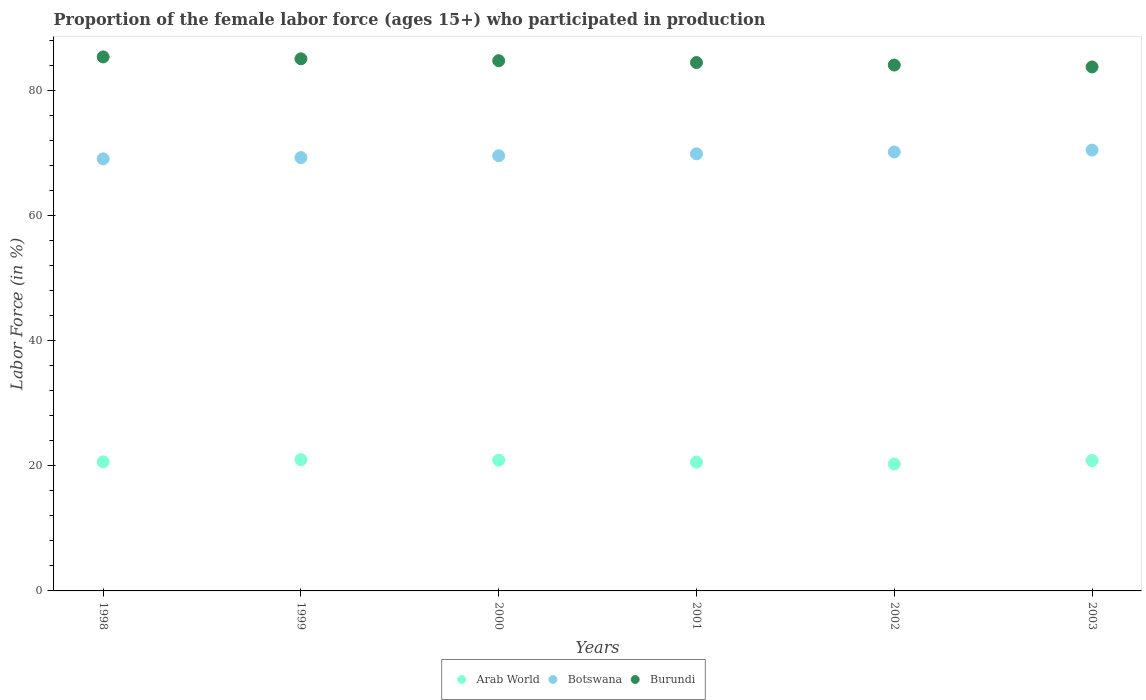What is the proportion of the female labor force who participated in production in Arab World in 2000?
Ensure brevity in your answer.  20.91. Across all years, what is the maximum proportion of the female labor force who participated in production in Burundi?
Ensure brevity in your answer.  85.4. Across all years, what is the minimum proportion of the female labor force who participated in production in Burundi?
Give a very brief answer. 83.8. What is the total proportion of the female labor force who participated in production in Burundi in the graph?
Ensure brevity in your answer.  507.7. What is the difference between the proportion of the female labor force who participated in production in Burundi in 2000 and the proportion of the female labor force who participated in production in Arab World in 2001?
Your answer should be compact. 64.21. What is the average proportion of the female labor force who participated in production in Burundi per year?
Your response must be concise. 84.62. In the year 1999, what is the difference between the proportion of the female labor force who participated in production in Arab World and proportion of the female labor force who participated in production in Burundi?
Ensure brevity in your answer.  -64.11. In how many years, is the proportion of the female labor force who participated in production in Arab World greater than 72 %?
Keep it short and to the point. 0. What is the ratio of the proportion of the female labor force who participated in production in Botswana in 2000 to that in 2003?
Offer a very short reply. 0.99. Is the difference between the proportion of the female labor force who participated in production in Arab World in 1999 and 2001 greater than the difference between the proportion of the female labor force who participated in production in Burundi in 1999 and 2001?
Your response must be concise. No. What is the difference between the highest and the second highest proportion of the female labor force who participated in production in Burundi?
Offer a very short reply. 0.3. What is the difference between the highest and the lowest proportion of the female labor force who participated in production in Arab World?
Provide a short and direct response. 0.69. In how many years, is the proportion of the female labor force who participated in production in Arab World greater than the average proportion of the female labor force who participated in production in Arab World taken over all years?
Make the answer very short. 3. Does the proportion of the female labor force who participated in production in Burundi monotonically increase over the years?
Give a very brief answer. No. Is the proportion of the female labor force who participated in production in Burundi strictly greater than the proportion of the female labor force who participated in production in Botswana over the years?
Provide a succinct answer. Yes. How many dotlines are there?
Give a very brief answer. 3. How many years are there in the graph?
Your answer should be very brief. 6. How many legend labels are there?
Ensure brevity in your answer.  3. What is the title of the graph?
Keep it short and to the point. Proportion of the female labor force (ages 15+) who participated in production. What is the label or title of the X-axis?
Make the answer very short. Years. What is the label or title of the Y-axis?
Your response must be concise. Labor Force (in %). What is the Labor Force (in %) of Arab World in 1998?
Provide a succinct answer. 20.64. What is the Labor Force (in %) in Botswana in 1998?
Your answer should be compact. 69.1. What is the Labor Force (in %) of Burundi in 1998?
Your answer should be very brief. 85.4. What is the Labor Force (in %) of Arab World in 1999?
Your answer should be compact. 20.99. What is the Labor Force (in %) in Botswana in 1999?
Offer a very short reply. 69.3. What is the Labor Force (in %) in Burundi in 1999?
Ensure brevity in your answer.  85.1. What is the Labor Force (in %) of Arab World in 2000?
Your response must be concise. 20.91. What is the Labor Force (in %) in Botswana in 2000?
Offer a very short reply. 69.6. What is the Labor Force (in %) in Burundi in 2000?
Make the answer very short. 84.8. What is the Labor Force (in %) of Arab World in 2001?
Make the answer very short. 20.59. What is the Labor Force (in %) in Botswana in 2001?
Offer a very short reply. 69.9. What is the Labor Force (in %) in Burundi in 2001?
Ensure brevity in your answer.  84.5. What is the Labor Force (in %) in Arab World in 2002?
Provide a succinct answer. 20.3. What is the Labor Force (in %) in Botswana in 2002?
Offer a very short reply. 70.2. What is the Labor Force (in %) of Burundi in 2002?
Provide a succinct answer. 84.1. What is the Labor Force (in %) of Arab World in 2003?
Give a very brief answer. 20.85. What is the Labor Force (in %) in Botswana in 2003?
Give a very brief answer. 70.5. What is the Labor Force (in %) in Burundi in 2003?
Give a very brief answer. 83.8. Across all years, what is the maximum Labor Force (in %) in Arab World?
Ensure brevity in your answer.  20.99. Across all years, what is the maximum Labor Force (in %) of Botswana?
Keep it short and to the point. 70.5. Across all years, what is the maximum Labor Force (in %) of Burundi?
Offer a terse response. 85.4. Across all years, what is the minimum Labor Force (in %) of Arab World?
Your answer should be compact. 20.3. Across all years, what is the minimum Labor Force (in %) of Botswana?
Give a very brief answer. 69.1. Across all years, what is the minimum Labor Force (in %) of Burundi?
Your response must be concise. 83.8. What is the total Labor Force (in %) of Arab World in the graph?
Provide a short and direct response. 124.28. What is the total Labor Force (in %) in Botswana in the graph?
Your answer should be very brief. 418.6. What is the total Labor Force (in %) in Burundi in the graph?
Your answer should be compact. 507.7. What is the difference between the Labor Force (in %) in Arab World in 1998 and that in 1999?
Provide a succinct answer. -0.35. What is the difference between the Labor Force (in %) in Botswana in 1998 and that in 1999?
Offer a terse response. -0.2. What is the difference between the Labor Force (in %) in Arab World in 1998 and that in 2000?
Offer a very short reply. -0.27. What is the difference between the Labor Force (in %) of Botswana in 1998 and that in 2000?
Keep it short and to the point. -0.5. What is the difference between the Labor Force (in %) of Burundi in 1998 and that in 2000?
Provide a succinct answer. 0.6. What is the difference between the Labor Force (in %) in Arab World in 1998 and that in 2001?
Give a very brief answer. 0.05. What is the difference between the Labor Force (in %) of Arab World in 1998 and that in 2002?
Your response must be concise. 0.34. What is the difference between the Labor Force (in %) in Burundi in 1998 and that in 2002?
Offer a terse response. 1.3. What is the difference between the Labor Force (in %) in Arab World in 1998 and that in 2003?
Ensure brevity in your answer.  -0.21. What is the difference between the Labor Force (in %) of Botswana in 1998 and that in 2003?
Keep it short and to the point. -1.4. What is the difference between the Labor Force (in %) of Arab World in 1999 and that in 2000?
Offer a very short reply. 0.08. What is the difference between the Labor Force (in %) in Botswana in 1999 and that in 2000?
Offer a terse response. -0.3. What is the difference between the Labor Force (in %) of Arab World in 1999 and that in 2001?
Your answer should be compact. 0.4. What is the difference between the Labor Force (in %) of Botswana in 1999 and that in 2001?
Your response must be concise. -0.6. What is the difference between the Labor Force (in %) in Burundi in 1999 and that in 2001?
Provide a short and direct response. 0.6. What is the difference between the Labor Force (in %) in Arab World in 1999 and that in 2002?
Give a very brief answer. 0.69. What is the difference between the Labor Force (in %) of Burundi in 1999 and that in 2002?
Your answer should be compact. 1. What is the difference between the Labor Force (in %) in Arab World in 1999 and that in 2003?
Provide a succinct answer. 0.14. What is the difference between the Labor Force (in %) of Burundi in 1999 and that in 2003?
Offer a terse response. 1.3. What is the difference between the Labor Force (in %) of Arab World in 2000 and that in 2001?
Your response must be concise. 0.32. What is the difference between the Labor Force (in %) in Burundi in 2000 and that in 2001?
Your response must be concise. 0.3. What is the difference between the Labor Force (in %) in Arab World in 2000 and that in 2002?
Provide a short and direct response. 0.61. What is the difference between the Labor Force (in %) of Burundi in 2000 and that in 2002?
Your answer should be very brief. 0.7. What is the difference between the Labor Force (in %) of Arab World in 2000 and that in 2003?
Keep it short and to the point. 0.07. What is the difference between the Labor Force (in %) in Botswana in 2000 and that in 2003?
Your response must be concise. -0.9. What is the difference between the Labor Force (in %) of Arab World in 2001 and that in 2002?
Ensure brevity in your answer.  0.29. What is the difference between the Labor Force (in %) in Arab World in 2001 and that in 2003?
Keep it short and to the point. -0.25. What is the difference between the Labor Force (in %) in Burundi in 2001 and that in 2003?
Offer a very short reply. 0.7. What is the difference between the Labor Force (in %) of Arab World in 2002 and that in 2003?
Make the answer very short. -0.55. What is the difference between the Labor Force (in %) of Botswana in 2002 and that in 2003?
Offer a very short reply. -0.3. What is the difference between the Labor Force (in %) of Burundi in 2002 and that in 2003?
Offer a terse response. 0.3. What is the difference between the Labor Force (in %) in Arab World in 1998 and the Labor Force (in %) in Botswana in 1999?
Your response must be concise. -48.66. What is the difference between the Labor Force (in %) in Arab World in 1998 and the Labor Force (in %) in Burundi in 1999?
Offer a terse response. -64.46. What is the difference between the Labor Force (in %) of Arab World in 1998 and the Labor Force (in %) of Botswana in 2000?
Ensure brevity in your answer.  -48.96. What is the difference between the Labor Force (in %) of Arab World in 1998 and the Labor Force (in %) of Burundi in 2000?
Provide a short and direct response. -64.16. What is the difference between the Labor Force (in %) of Botswana in 1998 and the Labor Force (in %) of Burundi in 2000?
Keep it short and to the point. -15.7. What is the difference between the Labor Force (in %) of Arab World in 1998 and the Labor Force (in %) of Botswana in 2001?
Ensure brevity in your answer.  -49.26. What is the difference between the Labor Force (in %) in Arab World in 1998 and the Labor Force (in %) in Burundi in 2001?
Ensure brevity in your answer.  -63.86. What is the difference between the Labor Force (in %) in Botswana in 1998 and the Labor Force (in %) in Burundi in 2001?
Keep it short and to the point. -15.4. What is the difference between the Labor Force (in %) of Arab World in 1998 and the Labor Force (in %) of Botswana in 2002?
Ensure brevity in your answer.  -49.56. What is the difference between the Labor Force (in %) of Arab World in 1998 and the Labor Force (in %) of Burundi in 2002?
Give a very brief answer. -63.46. What is the difference between the Labor Force (in %) in Arab World in 1998 and the Labor Force (in %) in Botswana in 2003?
Keep it short and to the point. -49.86. What is the difference between the Labor Force (in %) of Arab World in 1998 and the Labor Force (in %) of Burundi in 2003?
Provide a short and direct response. -63.16. What is the difference between the Labor Force (in %) in Botswana in 1998 and the Labor Force (in %) in Burundi in 2003?
Give a very brief answer. -14.7. What is the difference between the Labor Force (in %) in Arab World in 1999 and the Labor Force (in %) in Botswana in 2000?
Ensure brevity in your answer.  -48.61. What is the difference between the Labor Force (in %) in Arab World in 1999 and the Labor Force (in %) in Burundi in 2000?
Your response must be concise. -63.81. What is the difference between the Labor Force (in %) in Botswana in 1999 and the Labor Force (in %) in Burundi in 2000?
Your response must be concise. -15.5. What is the difference between the Labor Force (in %) in Arab World in 1999 and the Labor Force (in %) in Botswana in 2001?
Keep it short and to the point. -48.91. What is the difference between the Labor Force (in %) of Arab World in 1999 and the Labor Force (in %) of Burundi in 2001?
Keep it short and to the point. -63.51. What is the difference between the Labor Force (in %) in Botswana in 1999 and the Labor Force (in %) in Burundi in 2001?
Provide a succinct answer. -15.2. What is the difference between the Labor Force (in %) of Arab World in 1999 and the Labor Force (in %) of Botswana in 2002?
Ensure brevity in your answer.  -49.21. What is the difference between the Labor Force (in %) in Arab World in 1999 and the Labor Force (in %) in Burundi in 2002?
Provide a short and direct response. -63.11. What is the difference between the Labor Force (in %) of Botswana in 1999 and the Labor Force (in %) of Burundi in 2002?
Give a very brief answer. -14.8. What is the difference between the Labor Force (in %) in Arab World in 1999 and the Labor Force (in %) in Botswana in 2003?
Provide a succinct answer. -49.51. What is the difference between the Labor Force (in %) of Arab World in 1999 and the Labor Force (in %) of Burundi in 2003?
Offer a terse response. -62.81. What is the difference between the Labor Force (in %) in Botswana in 1999 and the Labor Force (in %) in Burundi in 2003?
Give a very brief answer. -14.5. What is the difference between the Labor Force (in %) of Arab World in 2000 and the Labor Force (in %) of Botswana in 2001?
Provide a succinct answer. -48.99. What is the difference between the Labor Force (in %) in Arab World in 2000 and the Labor Force (in %) in Burundi in 2001?
Make the answer very short. -63.59. What is the difference between the Labor Force (in %) of Botswana in 2000 and the Labor Force (in %) of Burundi in 2001?
Your answer should be compact. -14.9. What is the difference between the Labor Force (in %) in Arab World in 2000 and the Labor Force (in %) in Botswana in 2002?
Make the answer very short. -49.29. What is the difference between the Labor Force (in %) of Arab World in 2000 and the Labor Force (in %) of Burundi in 2002?
Give a very brief answer. -63.19. What is the difference between the Labor Force (in %) of Arab World in 2000 and the Labor Force (in %) of Botswana in 2003?
Keep it short and to the point. -49.59. What is the difference between the Labor Force (in %) of Arab World in 2000 and the Labor Force (in %) of Burundi in 2003?
Your answer should be very brief. -62.89. What is the difference between the Labor Force (in %) of Botswana in 2000 and the Labor Force (in %) of Burundi in 2003?
Offer a very short reply. -14.2. What is the difference between the Labor Force (in %) in Arab World in 2001 and the Labor Force (in %) in Botswana in 2002?
Your answer should be compact. -49.61. What is the difference between the Labor Force (in %) in Arab World in 2001 and the Labor Force (in %) in Burundi in 2002?
Provide a succinct answer. -63.51. What is the difference between the Labor Force (in %) of Arab World in 2001 and the Labor Force (in %) of Botswana in 2003?
Ensure brevity in your answer.  -49.91. What is the difference between the Labor Force (in %) in Arab World in 2001 and the Labor Force (in %) in Burundi in 2003?
Make the answer very short. -63.21. What is the difference between the Labor Force (in %) of Botswana in 2001 and the Labor Force (in %) of Burundi in 2003?
Keep it short and to the point. -13.9. What is the difference between the Labor Force (in %) in Arab World in 2002 and the Labor Force (in %) in Botswana in 2003?
Offer a terse response. -50.2. What is the difference between the Labor Force (in %) of Arab World in 2002 and the Labor Force (in %) of Burundi in 2003?
Make the answer very short. -63.5. What is the average Labor Force (in %) of Arab World per year?
Keep it short and to the point. 20.71. What is the average Labor Force (in %) in Botswana per year?
Provide a short and direct response. 69.77. What is the average Labor Force (in %) of Burundi per year?
Your answer should be compact. 84.62. In the year 1998, what is the difference between the Labor Force (in %) in Arab World and Labor Force (in %) in Botswana?
Offer a terse response. -48.46. In the year 1998, what is the difference between the Labor Force (in %) in Arab World and Labor Force (in %) in Burundi?
Make the answer very short. -64.76. In the year 1998, what is the difference between the Labor Force (in %) of Botswana and Labor Force (in %) of Burundi?
Provide a succinct answer. -16.3. In the year 1999, what is the difference between the Labor Force (in %) of Arab World and Labor Force (in %) of Botswana?
Your response must be concise. -48.31. In the year 1999, what is the difference between the Labor Force (in %) in Arab World and Labor Force (in %) in Burundi?
Give a very brief answer. -64.11. In the year 1999, what is the difference between the Labor Force (in %) of Botswana and Labor Force (in %) of Burundi?
Provide a short and direct response. -15.8. In the year 2000, what is the difference between the Labor Force (in %) of Arab World and Labor Force (in %) of Botswana?
Your response must be concise. -48.69. In the year 2000, what is the difference between the Labor Force (in %) of Arab World and Labor Force (in %) of Burundi?
Provide a short and direct response. -63.89. In the year 2000, what is the difference between the Labor Force (in %) in Botswana and Labor Force (in %) in Burundi?
Give a very brief answer. -15.2. In the year 2001, what is the difference between the Labor Force (in %) in Arab World and Labor Force (in %) in Botswana?
Your answer should be very brief. -49.31. In the year 2001, what is the difference between the Labor Force (in %) in Arab World and Labor Force (in %) in Burundi?
Provide a succinct answer. -63.91. In the year 2001, what is the difference between the Labor Force (in %) of Botswana and Labor Force (in %) of Burundi?
Make the answer very short. -14.6. In the year 2002, what is the difference between the Labor Force (in %) in Arab World and Labor Force (in %) in Botswana?
Make the answer very short. -49.9. In the year 2002, what is the difference between the Labor Force (in %) of Arab World and Labor Force (in %) of Burundi?
Your response must be concise. -63.8. In the year 2002, what is the difference between the Labor Force (in %) of Botswana and Labor Force (in %) of Burundi?
Provide a short and direct response. -13.9. In the year 2003, what is the difference between the Labor Force (in %) in Arab World and Labor Force (in %) in Botswana?
Your answer should be compact. -49.65. In the year 2003, what is the difference between the Labor Force (in %) of Arab World and Labor Force (in %) of Burundi?
Your response must be concise. -62.95. In the year 2003, what is the difference between the Labor Force (in %) of Botswana and Labor Force (in %) of Burundi?
Your response must be concise. -13.3. What is the ratio of the Labor Force (in %) of Arab World in 1998 to that in 1999?
Ensure brevity in your answer.  0.98. What is the ratio of the Labor Force (in %) in Arab World in 1998 to that in 2000?
Your answer should be compact. 0.99. What is the ratio of the Labor Force (in %) in Botswana in 1998 to that in 2000?
Ensure brevity in your answer.  0.99. What is the ratio of the Labor Force (in %) of Burundi in 1998 to that in 2000?
Your response must be concise. 1.01. What is the ratio of the Labor Force (in %) in Botswana in 1998 to that in 2001?
Offer a very short reply. 0.99. What is the ratio of the Labor Force (in %) in Burundi in 1998 to that in 2001?
Keep it short and to the point. 1.01. What is the ratio of the Labor Force (in %) in Arab World in 1998 to that in 2002?
Make the answer very short. 1.02. What is the ratio of the Labor Force (in %) in Botswana in 1998 to that in 2002?
Give a very brief answer. 0.98. What is the ratio of the Labor Force (in %) in Burundi in 1998 to that in 2002?
Offer a terse response. 1.02. What is the ratio of the Labor Force (in %) of Botswana in 1998 to that in 2003?
Offer a very short reply. 0.98. What is the ratio of the Labor Force (in %) in Burundi in 1998 to that in 2003?
Your answer should be compact. 1.02. What is the ratio of the Labor Force (in %) in Botswana in 1999 to that in 2000?
Give a very brief answer. 1. What is the ratio of the Labor Force (in %) in Burundi in 1999 to that in 2000?
Give a very brief answer. 1. What is the ratio of the Labor Force (in %) in Arab World in 1999 to that in 2001?
Provide a short and direct response. 1.02. What is the ratio of the Labor Force (in %) in Burundi in 1999 to that in 2001?
Ensure brevity in your answer.  1.01. What is the ratio of the Labor Force (in %) in Arab World in 1999 to that in 2002?
Keep it short and to the point. 1.03. What is the ratio of the Labor Force (in %) in Botswana in 1999 to that in 2002?
Your answer should be compact. 0.99. What is the ratio of the Labor Force (in %) in Burundi in 1999 to that in 2002?
Your response must be concise. 1.01. What is the ratio of the Labor Force (in %) of Burundi in 1999 to that in 2003?
Your response must be concise. 1.02. What is the ratio of the Labor Force (in %) in Arab World in 2000 to that in 2001?
Make the answer very short. 1.02. What is the ratio of the Labor Force (in %) of Burundi in 2000 to that in 2001?
Your answer should be compact. 1. What is the ratio of the Labor Force (in %) of Arab World in 2000 to that in 2002?
Ensure brevity in your answer.  1.03. What is the ratio of the Labor Force (in %) of Botswana in 2000 to that in 2002?
Provide a short and direct response. 0.99. What is the ratio of the Labor Force (in %) in Burundi in 2000 to that in 2002?
Provide a succinct answer. 1.01. What is the ratio of the Labor Force (in %) of Arab World in 2000 to that in 2003?
Give a very brief answer. 1. What is the ratio of the Labor Force (in %) of Botswana in 2000 to that in 2003?
Provide a succinct answer. 0.99. What is the ratio of the Labor Force (in %) in Burundi in 2000 to that in 2003?
Provide a short and direct response. 1.01. What is the ratio of the Labor Force (in %) in Arab World in 2001 to that in 2002?
Provide a short and direct response. 1.01. What is the ratio of the Labor Force (in %) in Arab World in 2001 to that in 2003?
Offer a terse response. 0.99. What is the ratio of the Labor Force (in %) in Burundi in 2001 to that in 2003?
Make the answer very short. 1.01. What is the ratio of the Labor Force (in %) in Arab World in 2002 to that in 2003?
Provide a succinct answer. 0.97. What is the ratio of the Labor Force (in %) of Botswana in 2002 to that in 2003?
Provide a short and direct response. 1. What is the ratio of the Labor Force (in %) of Burundi in 2002 to that in 2003?
Offer a very short reply. 1. What is the difference between the highest and the second highest Labor Force (in %) of Arab World?
Provide a short and direct response. 0.08. What is the difference between the highest and the second highest Labor Force (in %) of Botswana?
Provide a succinct answer. 0.3. What is the difference between the highest and the lowest Labor Force (in %) in Arab World?
Offer a very short reply. 0.69. 